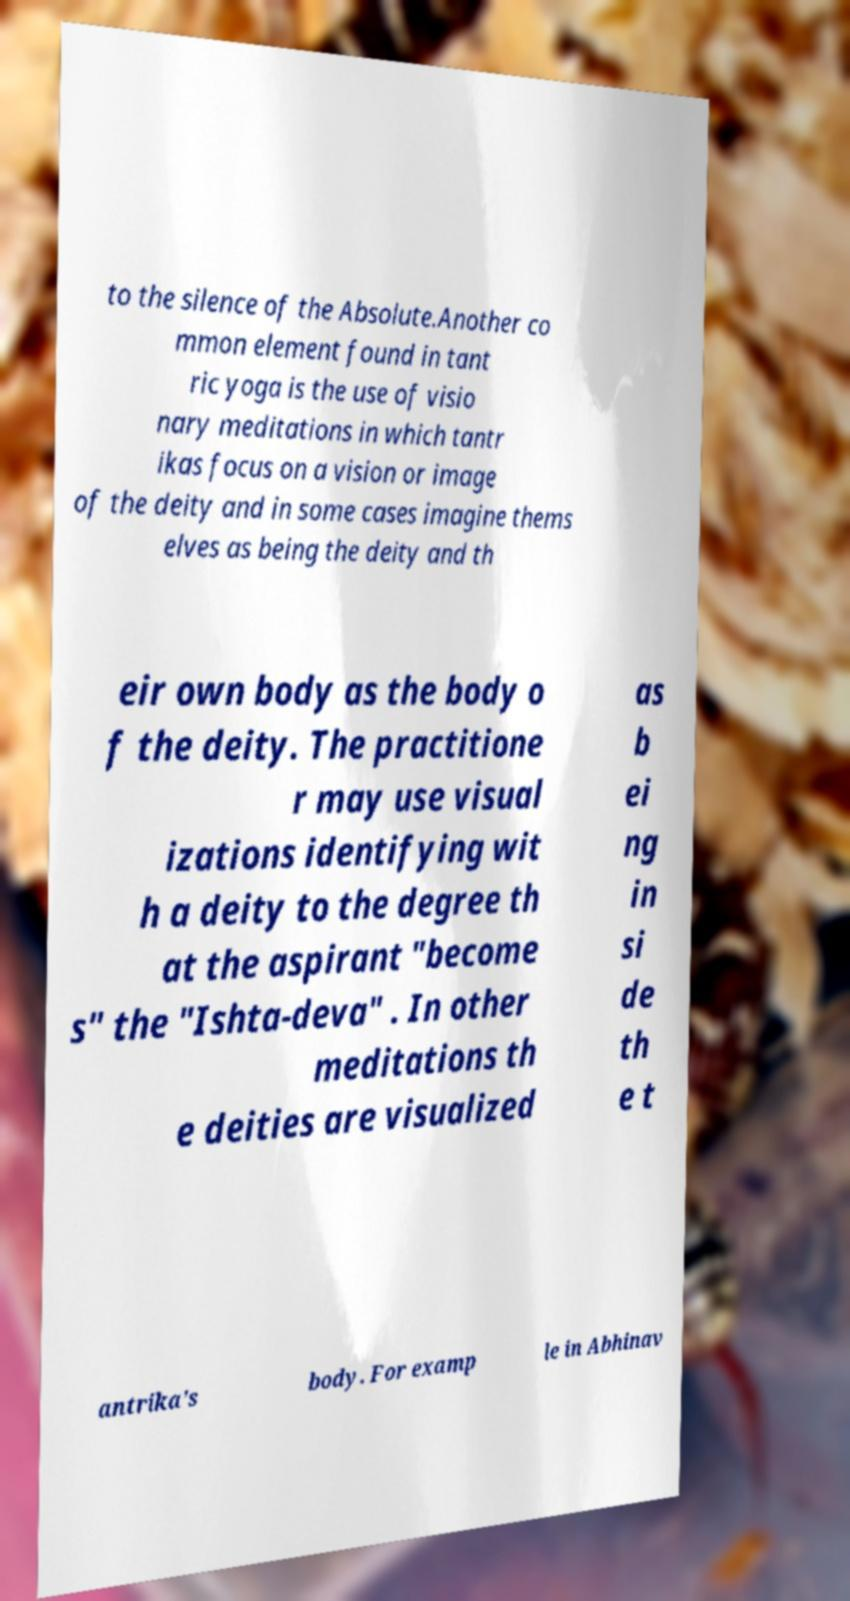Could you assist in decoding the text presented in this image and type it out clearly? to the silence of the Absolute.Another co mmon element found in tant ric yoga is the use of visio nary meditations in which tantr ikas focus on a vision or image of the deity and in some cases imagine thems elves as being the deity and th eir own body as the body o f the deity. The practitione r may use visual izations identifying wit h a deity to the degree th at the aspirant "become s" the "Ishta-deva" . In other meditations th e deities are visualized as b ei ng in si de th e t antrika's body. For examp le in Abhinav 